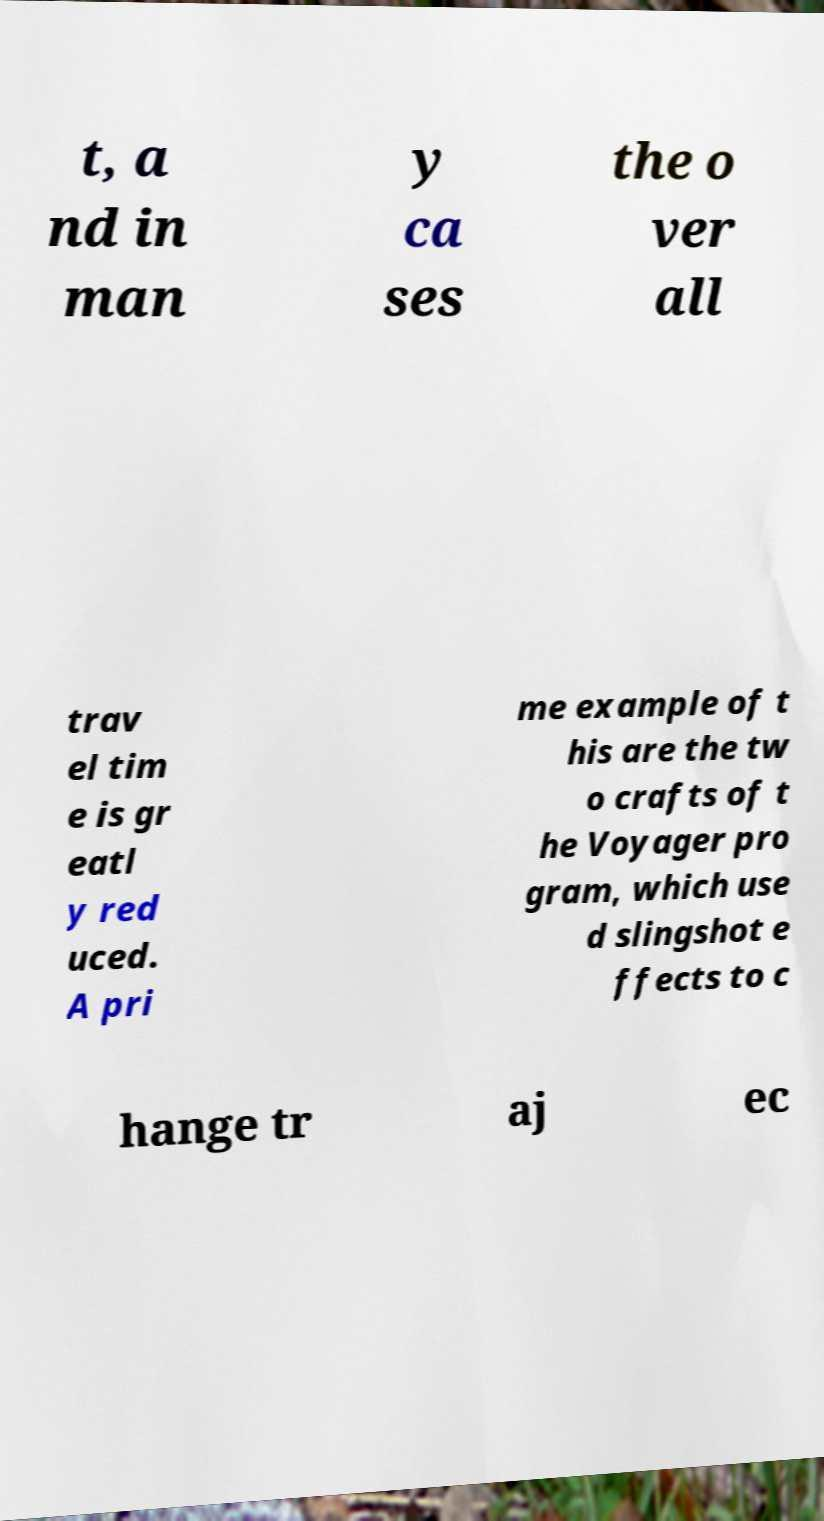For documentation purposes, I need the text within this image transcribed. Could you provide that? t, a nd in man y ca ses the o ver all trav el tim e is gr eatl y red uced. A pri me example of t his are the tw o crafts of t he Voyager pro gram, which use d slingshot e ffects to c hange tr aj ec 